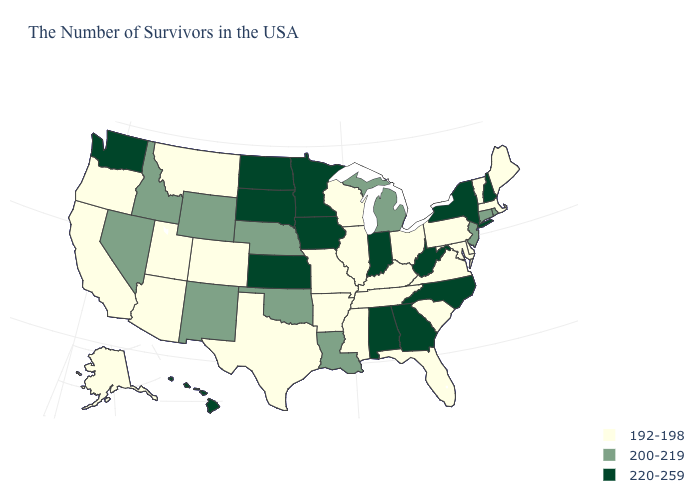What is the lowest value in the USA?
Answer briefly. 192-198. What is the value of Delaware?
Give a very brief answer. 192-198. What is the value of Pennsylvania?
Quick response, please. 192-198. Does Wyoming have the lowest value in the USA?
Be succinct. No. What is the value of West Virginia?
Answer briefly. 220-259. Name the states that have a value in the range 192-198?
Concise answer only. Maine, Massachusetts, Vermont, Delaware, Maryland, Pennsylvania, Virginia, South Carolina, Ohio, Florida, Kentucky, Tennessee, Wisconsin, Illinois, Mississippi, Missouri, Arkansas, Texas, Colorado, Utah, Montana, Arizona, California, Oregon, Alaska. Does Hawaii have the highest value in the West?
Write a very short answer. Yes. Does Nevada have the same value as Kentucky?
Write a very short answer. No. Which states have the lowest value in the USA?
Be succinct. Maine, Massachusetts, Vermont, Delaware, Maryland, Pennsylvania, Virginia, South Carolina, Ohio, Florida, Kentucky, Tennessee, Wisconsin, Illinois, Mississippi, Missouri, Arkansas, Texas, Colorado, Utah, Montana, Arizona, California, Oregon, Alaska. What is the value of Montana?
Short answer required. 192-198. Does the map have missing data?
Quick response, please. No. What is the value of Georgia?
Concise answer only. 220-259. Does the first symbol in the legend represent the smallest category?
Write a very short answer. Yes. What is the value of Utah?
Answer briefly. 192-198. 